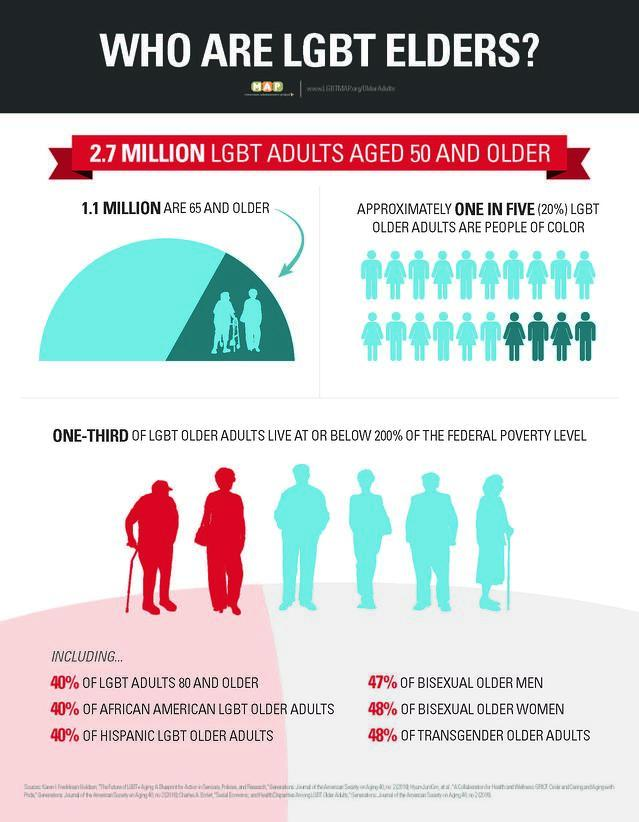Give some essential details in this illustration. The population of LGBT elders who are aged 65 and above is approximately 1.1 million. 